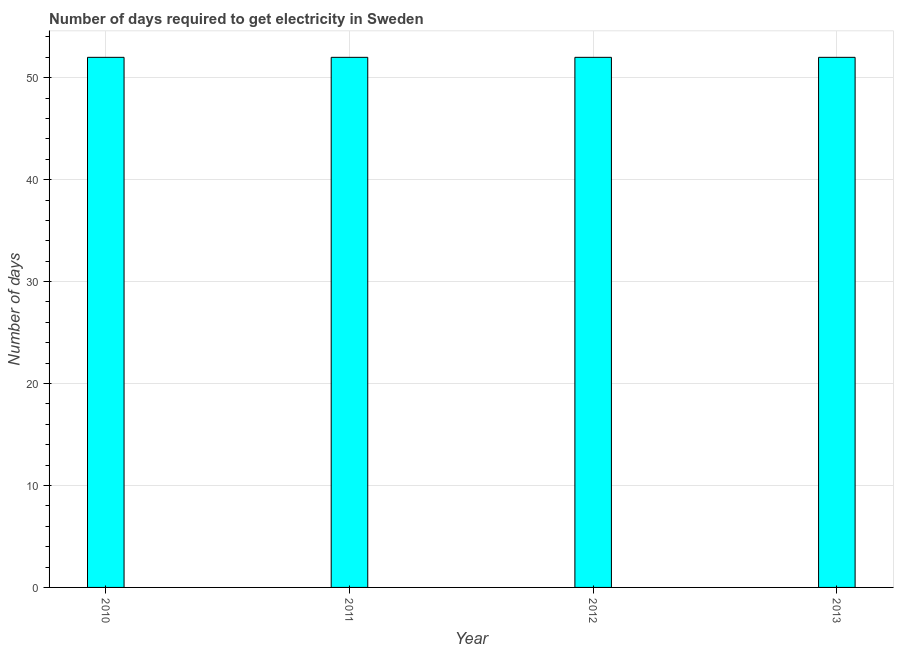Does the graph contain any zero values?
Keep it short and to the point. No. Does the graph contain grids?
Keep it short and to the point. Yes. What is the title of the graph?
Ensure brevity in your answer.  Number of days required to get electricity in Sweden. What is the label or title of the X-axis?
Make the answer very short. Year. What is the label or title of the Y-axis?
Offer a terse response. Number of days. What is the time to get electricity in 2011?
Provide a succinct answer. 52. Across all years, what is the maximum time to get electricity?
Ensure brevity in your answer.  52. Across all years, what is the minimum time to get electricity?
Offer a very short reply. 52. In which year was the time to get electricity maximum?
Provide a short and direct response. 2010. In which year was the time to get electricity minimum?
Your answer should be compact. 2010. What is the sum of the time to get electricity?
Offer a very short reply. 208. What is the average time to get electricity per year?
Your answer should be compact. 52. In how many years, is the time to get electricity greater than 12 ?
Offer a very short reply. 4. Is the time to get electricity in 2010 less than that in 2013?
Offer a very short reply. No. Is the difference between the time to get electricity in 2011 and 2012 greater than the difference between any two years?
Ensure brevity in your answer.  Yes. What is the difference between the highest and the second highest time to get electricity?
Provide a short and direct response. 0. Is the sum of the time to get electricity in 2011 and 2013 greater than the maximum time to get electricity across all years?
Make the answer very short. Yes. What is the difference between the highest and the lowest time to get electricity?
Keep it short and to the point. 0. Are all the bars in the graph horizontal?
Your answer should be very brief. No. What is the Number of days in 2013?
Provide a succinct answer. 52. What is the difference between the Number of days in 2010 and 2011?
Your answer should be very brief. 0. What is the difference between the Number of days in 2010 and 2013?
Give a very brief answer. 0. What is the difference between the Number of days in 2011 and 2012?
Offer a terse response. 0. What is the ratio of the Number of days in 2010 to that in 2011?
Your answer should be compact. 1. What is the ratio of the Number of days in 2010 to that in 2012?
Offer a terse response. 1. What is the ratio of the Number of days in 2010 to that in 2013?
Provide a succinct answer. 1. 